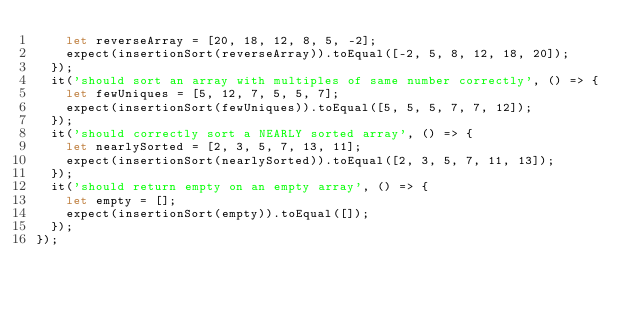Convert code to text. <code><loc_0><loc_0><loc_500><loc_500><_JavaScript_>    let reverseArray = [20, 18, 12, 8, 5, -2];
    expect(insertionSort(reverseArray)).toEqual([-2, 5, 8, 12, 18, 20]);
  });
  it('should sort an array with multiples of same number correctly', () => {
    let fewUniques = [5, 12, 7, 5, 5, 7];
    expect(insertionSort(fewUniques)).toEqual([5, 5, 5, 7, 7, 12]);
  });
  it('should correctly sort a NEARLY sorted array', () => {
    let nearlySorted = [2, 3, 5, 7, 13, 11];
    expect(insertionSort(nearlySorted)).toEqual([2, 3, 5, 7, 11, 13]);
  });
  it('should return empty on an empty array', () => {
    let empty = [];
    expect(insertionSort(empty)).toEqual([]);
  });
});
</code> 